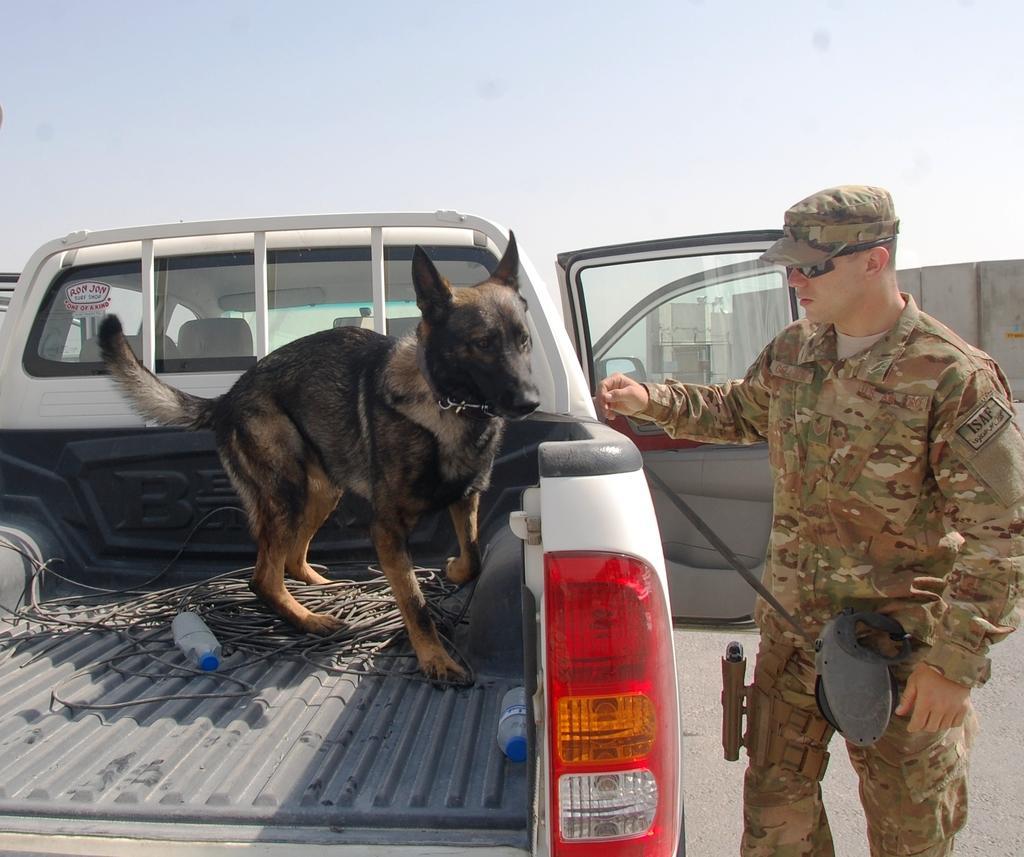Please provide a concise description of this image. In this image there is a vehicle and we can see a dog. There are bottles and wires placed in the vehicle. On the right there is a man standing. He is wearing uniform. In the background there is sky. 